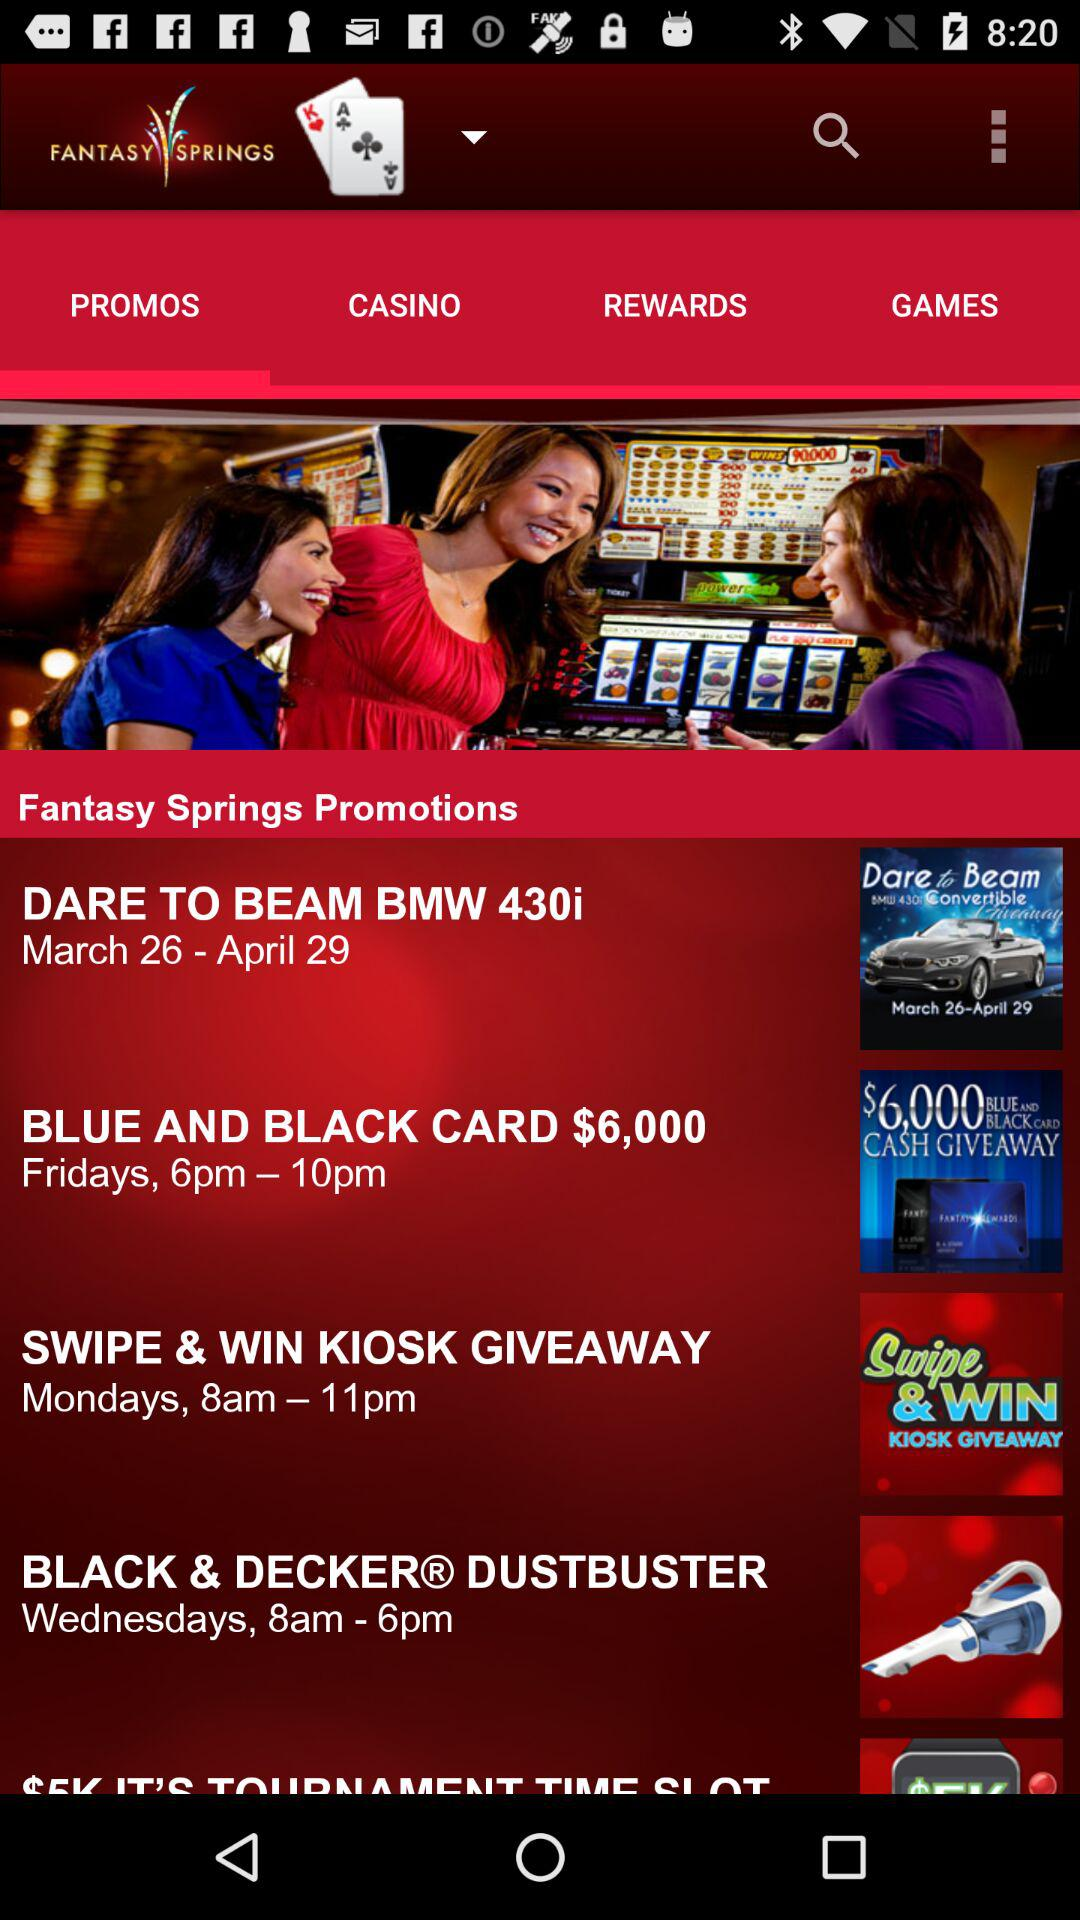What date and time are scheduled for the "SWIPE & WIN KIOSK GIVEAWAY"? The scheduled date and time for the "SWIPE & WIN KIOSK GIVEAWAY" are Mondays from 8 a.m. to 11 p.m. 